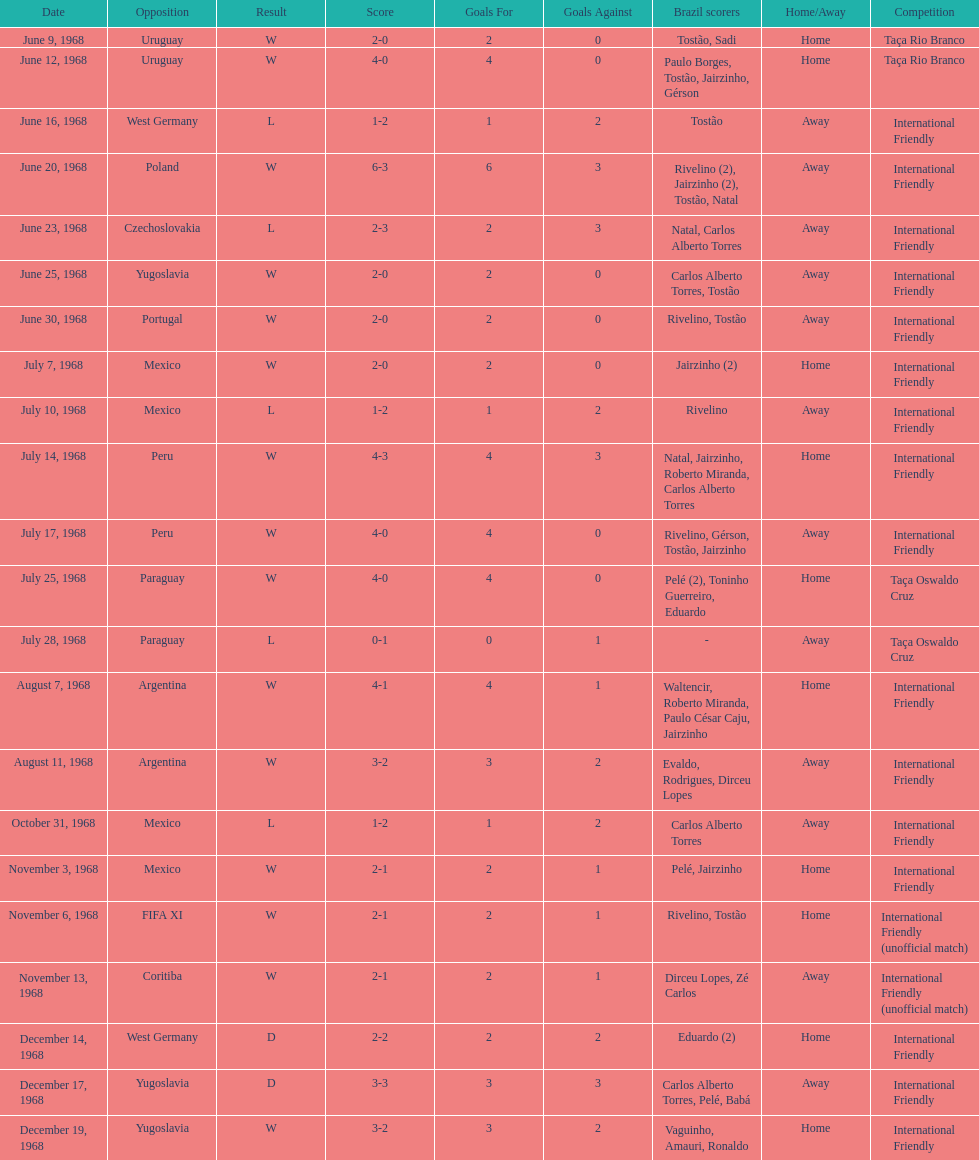What's the total number of ties? 2. 